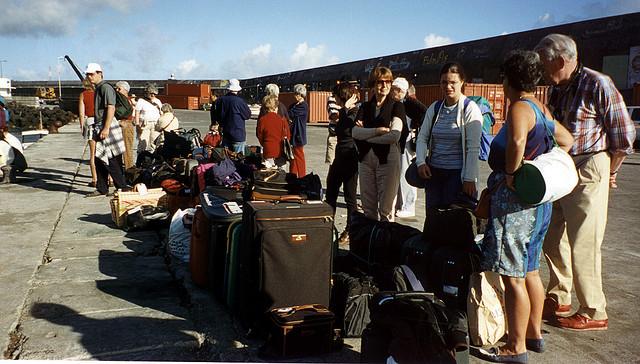Where is a brown suitcase?
Keep it brief. On ground. What is the man in the plaid shirt doing?
Write a very short answer. Standing. What sort of place is this?
Concise answer only. Airport. What color is the top bag on cart of the man in the center?
Give a very brief answer. Black. What are they doing?
Concise answer only. Waiting. Are the people going on a trip?
Short answer required. Yes. Is the sun on the left or right side of this picture?
Write a very short answer. Right. What are the people observing?
Be succinct. Luggage. 